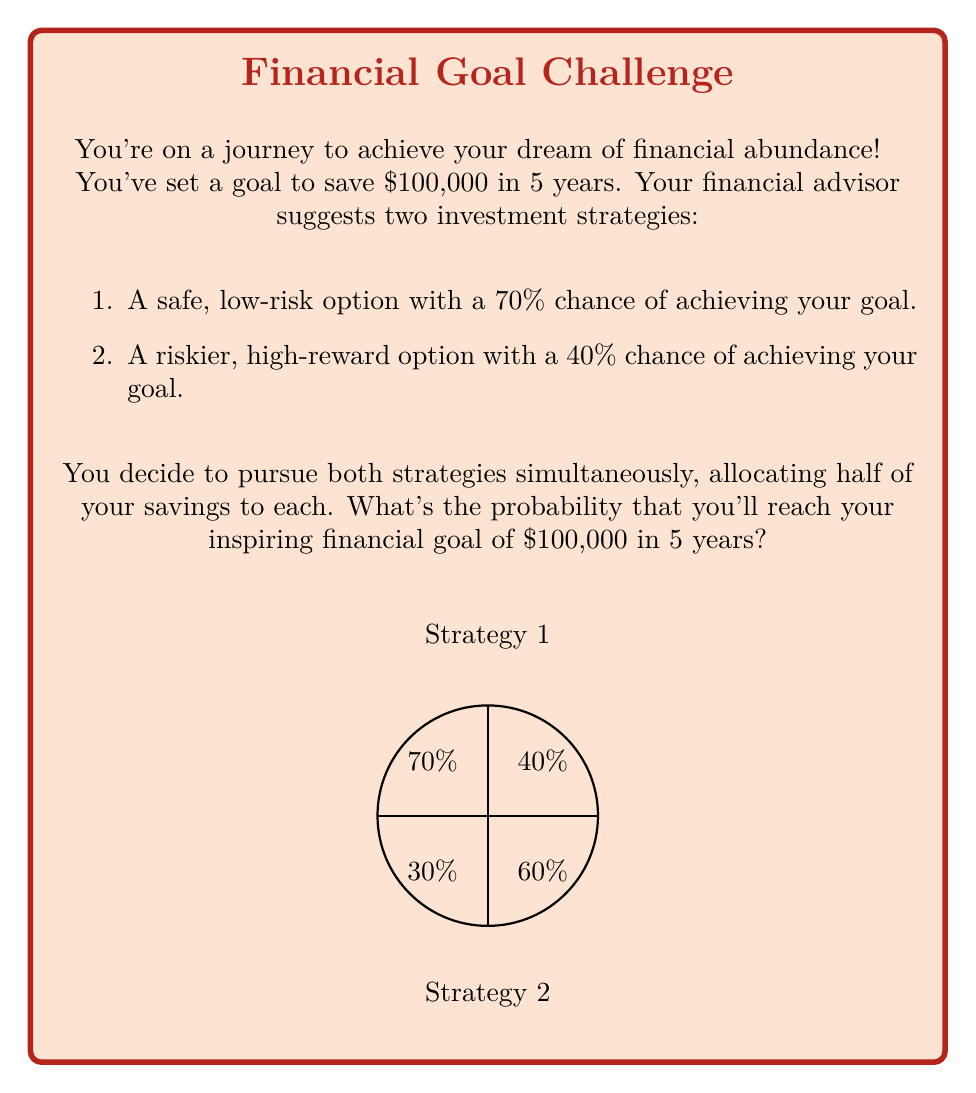Can you solve this math problem? Let's approach this step-by-step with a positive mindset!

1) First, we need to understand that for the overall goal to be achieved, at least one of the strategies needs to succeed.

2) It's easier to calculate the probability of failure and then subtract it from 1 to get the probability of success.

3) Probability of Strategy 1 failing: $1 - 0.70 = 0.30$ or 30%

4) Probability of Strategy 2 failing: $1 - 0.40 = 0.60$ or 60%

5) For the overall goal to fail, both strategies must fail. Since the strategies are independent, we multiply these probabilities:

   $P(\text{both fail}) = 0.30 * 0.60 = 0.18$ or 18%

6) Therefore, the probability of success is:

   $P(\text{success}) = 1 - P(\text{both fail}) = 1 - 0.18 = 0.82$ or 82%

7) We can also calculate this directly:

   $P(\text{success}) = 1 - (1-0.70)(1-0.40) = 1 - 0.30 * 0.60 = 1 - 0.18 = 0.82$

This means you have an 82% chance of achieving your inspiring financial goal!
Answer: 82% 